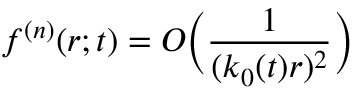Convert formula to latex. <formula><loc_0><loc_0><loc_500><loc_500>f ^ { ( n ) } ( r ; t ) = O \left ( \frac { 1 } { ( k _ { 0 } ( t ) r ) ^ { 2 } } \right )</formula> 